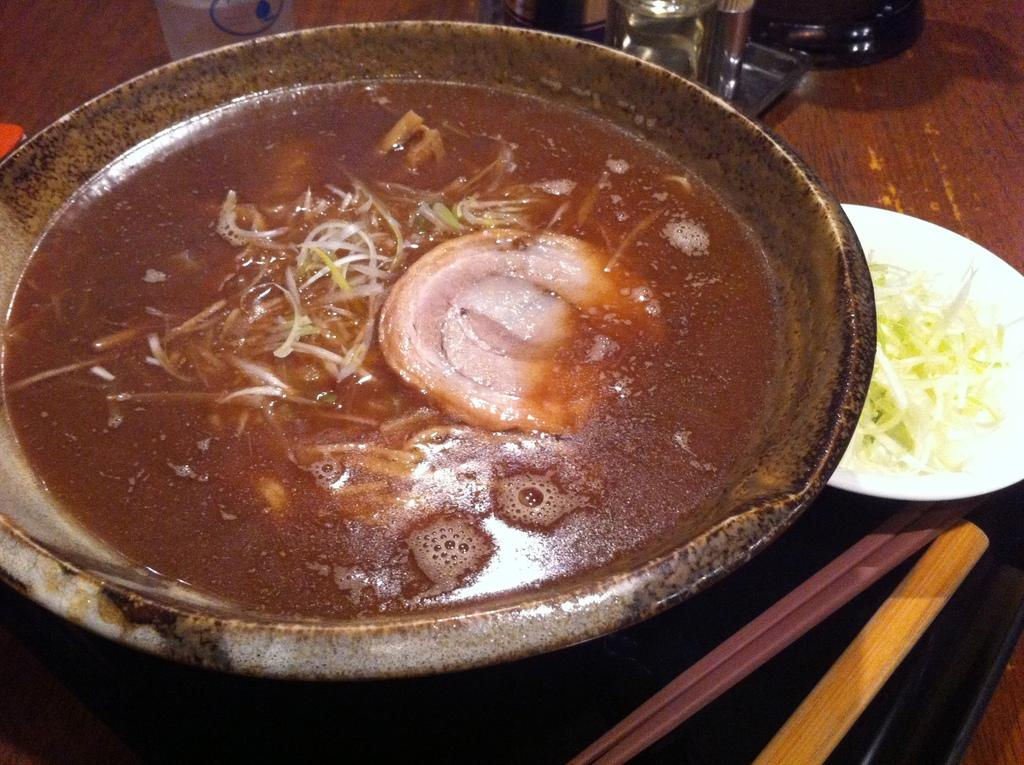What is on the dish that is visible in the image? There is a dish with food in the image. What else can be seen in the image that also contains food? There is a plate with food beside the dish in the image. What type of pot is visible in the image? There is no pot present in the image. Can you tell me how many breaths the person in the image is taking? There is no person present in the image, so it is impossible to determine the number of breaths they are taking. 